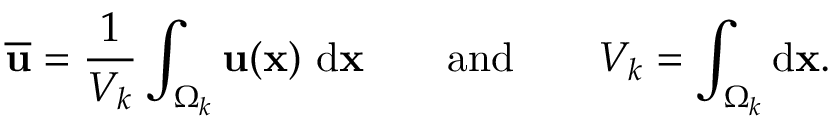Convert formula to latex. <formula><loc_0><loc_0><loc_500><loc_500>\overline { u } = \frac { 1 } { V _ { k } } \int _ { \Omega _ { k } } u ( x ) \ d x \quad a n d \quad V _ { k } = \int _ { \Omega _ { k } } d x .</formula> 